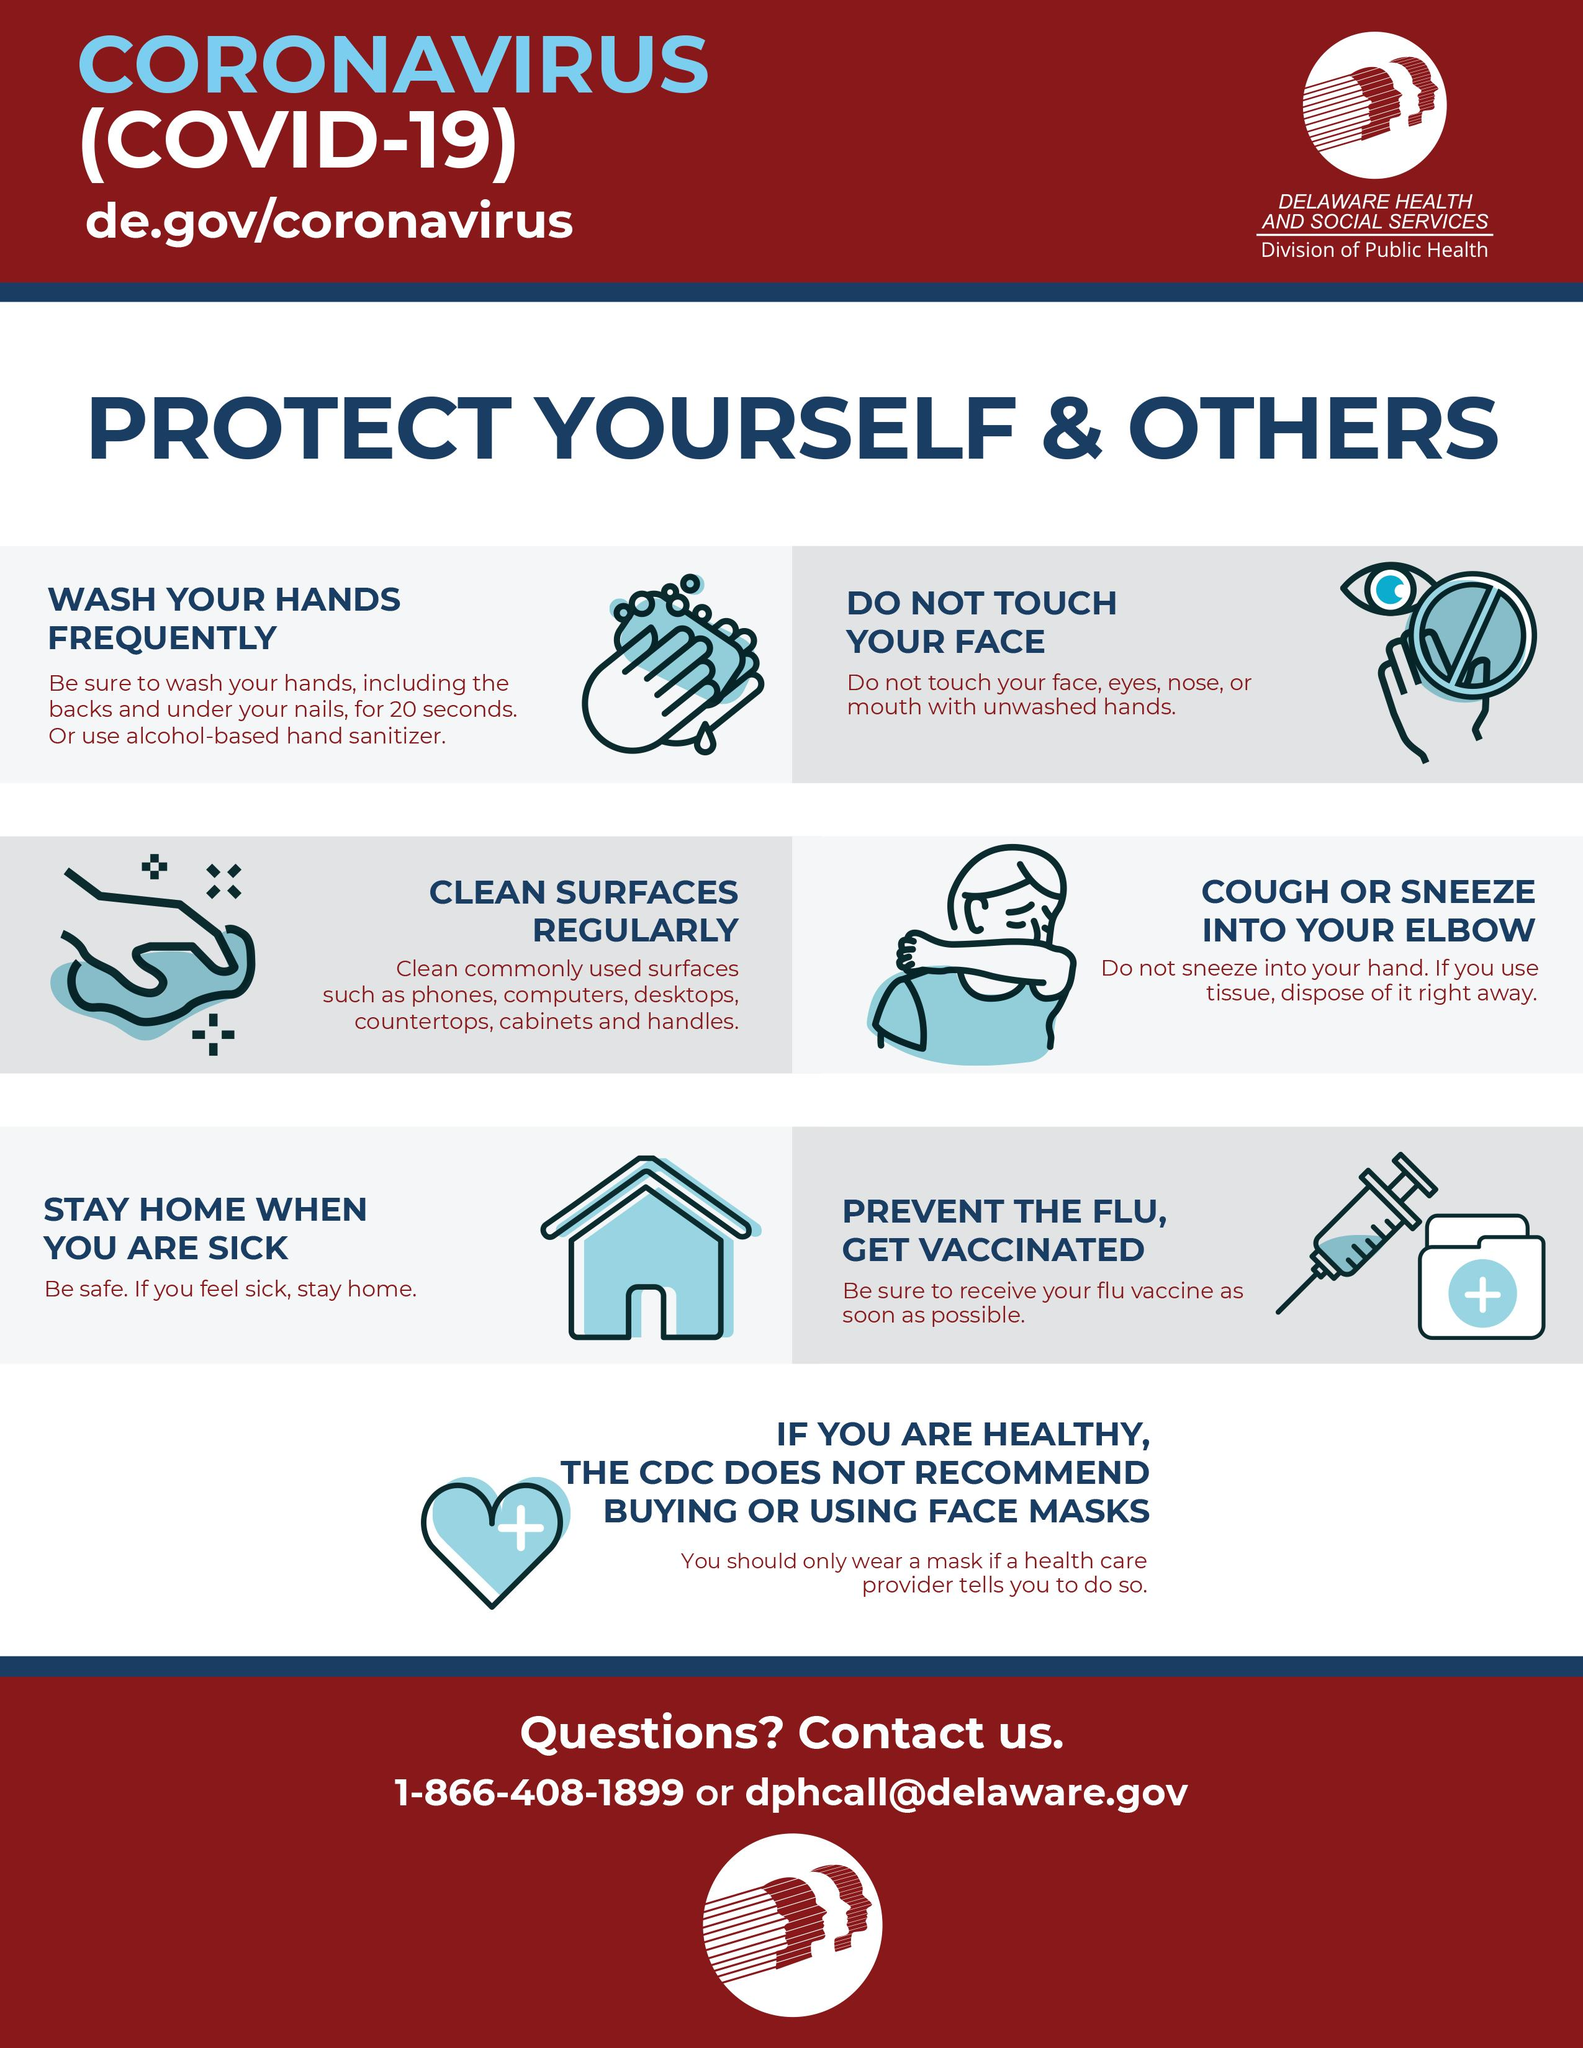Point out several critical features in this image. If someone is not well, they should stay home to ensure their health and well-being. It is recommended to use alcohol-based hand sanitizer if water is not available for hand cleaning, as it is an effective and quick method for minimizing the spread of germs and preventing the transmission of illness. It is advisable to avoid sneezing into one's hand, as it is recommended to sneeze into a tissue or a handkerchief. 